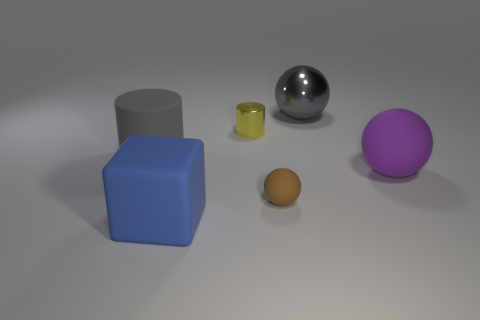Are the big purple thing and the tiny brown ball made of the same material?
Give a very brief answer. Yes. What number of other things are the same shape as the blue object?
Provide a short and direct response. 0. Is there anything else that has the same material as the small cylinder?
Your answer should be very brief. Yes. What is the color of the sphere that is behind the big rubber object to the left of the big rubber object in front of the purple matte sphere?
Your answer should be compact. Gray. There is a large object behind the rubber cylinder; is it the same shape as the tiny brown object?
Your answer should be very brief. Yes. What number of large cyan blocks are there?
Your answer should be very brief. 0. How many yellow shiny cylinders have the same size as the gray rubber thing?
Offer a terse response. 0. What is the material of the purple thing?
Ensure brevity in your answer.  Rubber. Is the color of the small matte object the same as the large rubber object right of the tiny cylinder?
Keep it short and to the point. No. There is a matte thing that is on the right side of the blue cube and on the left side of the metal sphere; what is its size?
Offer a very short reply. Small. 